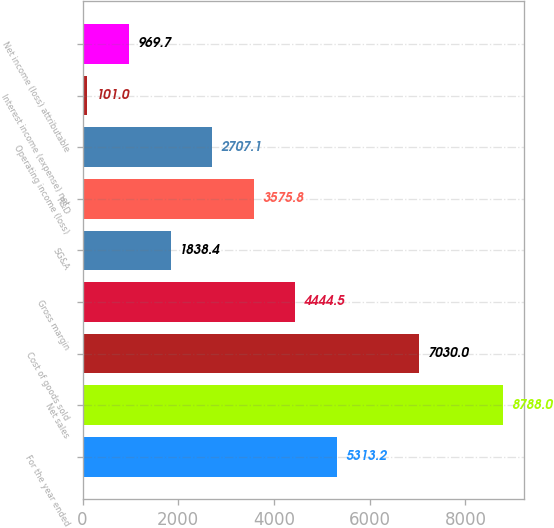<chart> <loc_0><loc_0><loc_500><loc_500><bar_chart><fcel>For the year ended<fcel>Net sales<fcel>Cost of goods sold<fcel>Gross margin<fcel>SG&A<fcel>R&D<fcel>Operating income (loss)<fcel>Interest income (expense) net<fcel>Net income (loss) attributable<nl><fcel>5313.2<fcel>8788<fcel>7030<fcel>4444.5<fcel>1838.4<fcel>3575.8<fcel>2707.1<fcel>101<fcel>969.7<nl></chart> 